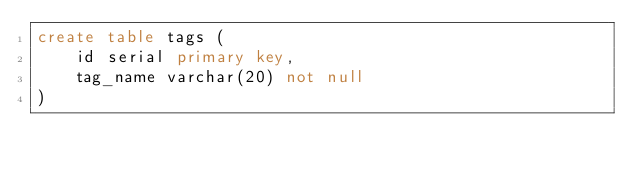Convert code to text. <code><loc_0><loc_0><loc_500><loc_500><_SQL_>create table tags (
    id serial primary key,
    tag_name varchar(20) not null
)</code> 